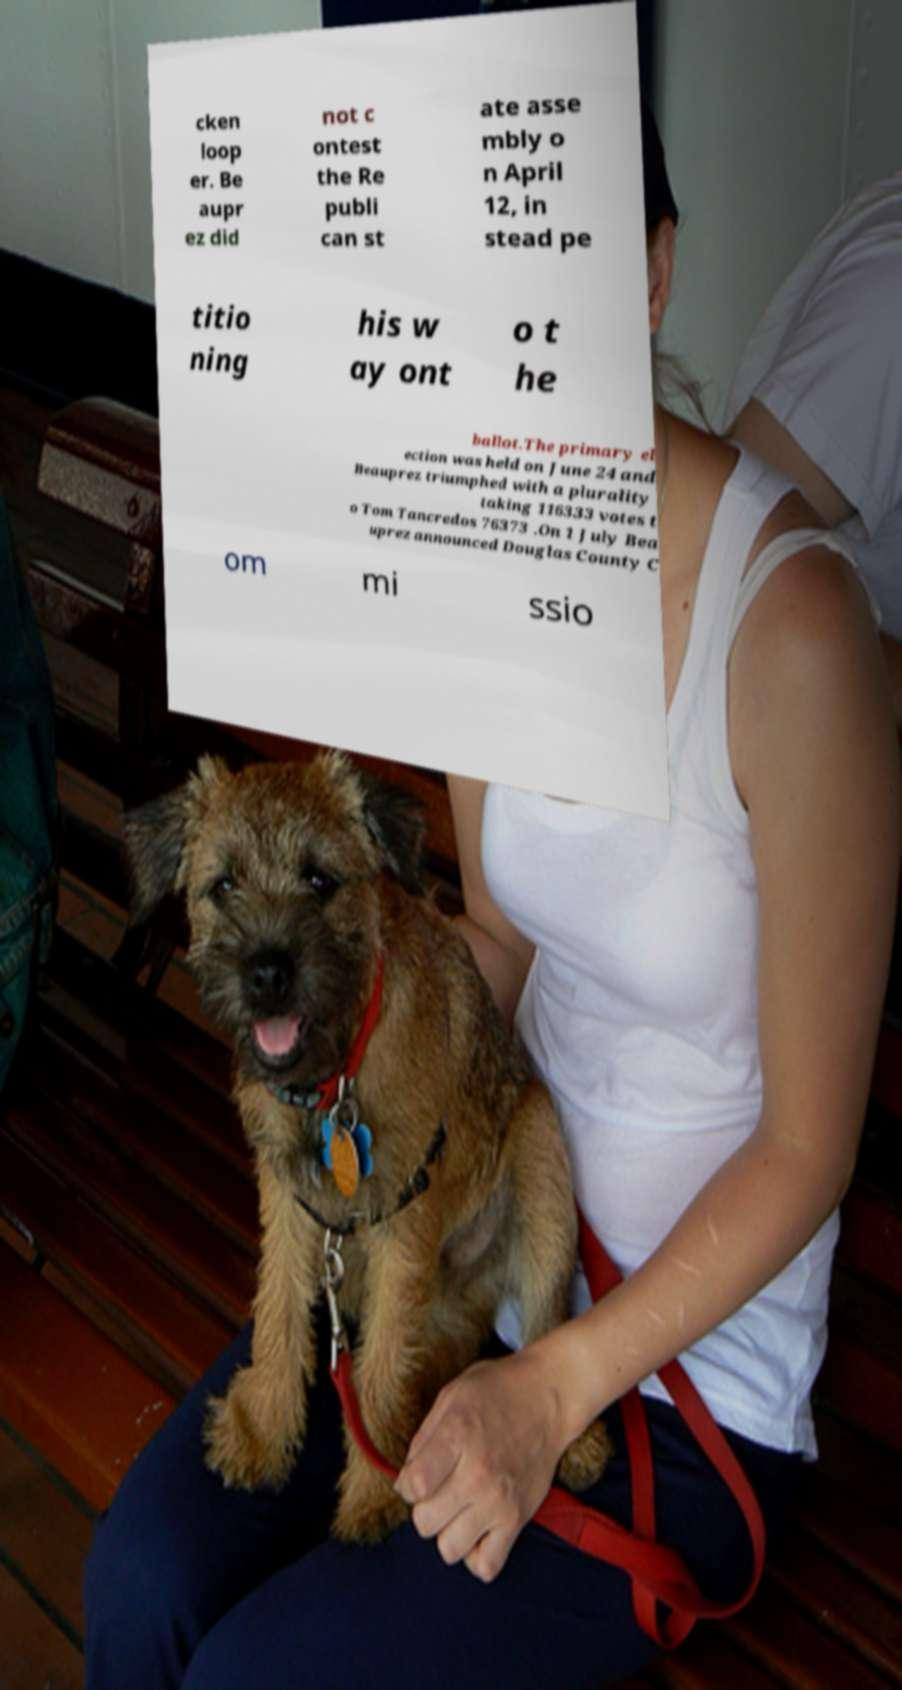Could you extract and type out the text from this image? cken loop er. Be aupr ez did not c ontest the Re publi can st ate asse mbly o n April 12, in stead pe titio ning his w ay ont o t he ballot.The primary el ection was held on June 24 and Beauprez triumphed with a plurality taking 116333 votes t o Tom Tancredos 76373 .On 1 July Bea uprez announced Douglas County C om mi ssio 